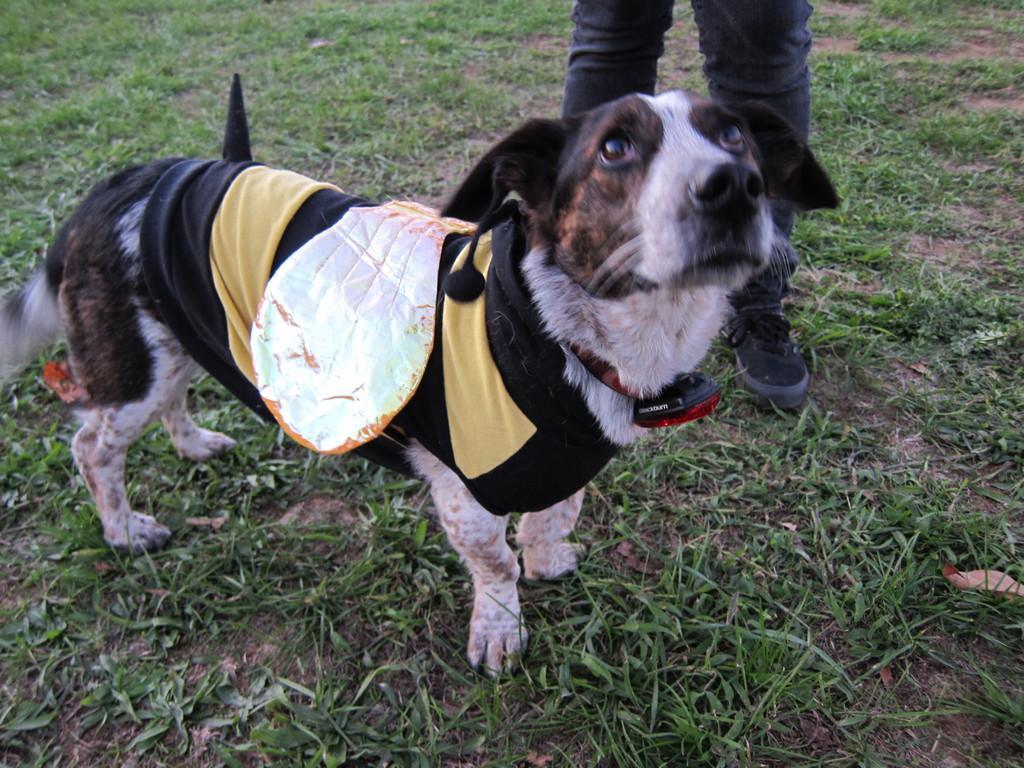Please provide a concise description of this image. Here there is a dog standing on the ground and behind it we can see a person standing and we can see only legs. 